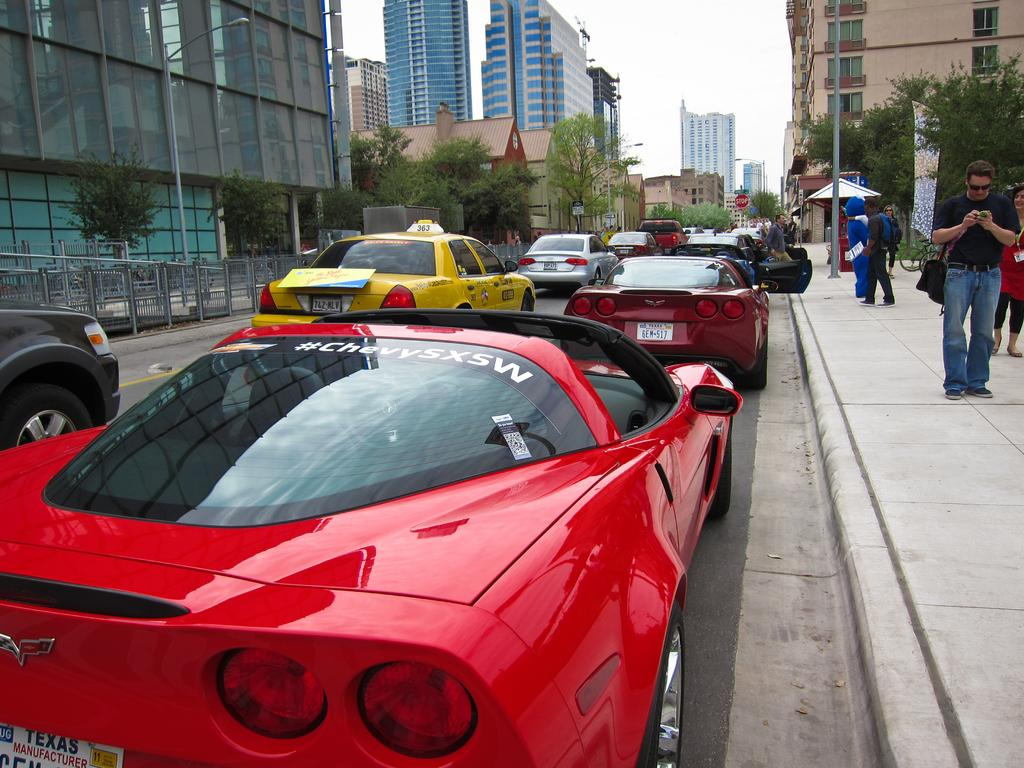Provide a one-sentence caption for the provided image. A red Corvette is next to a curb, with a "#ChevySXSW" on the rear windshield. 